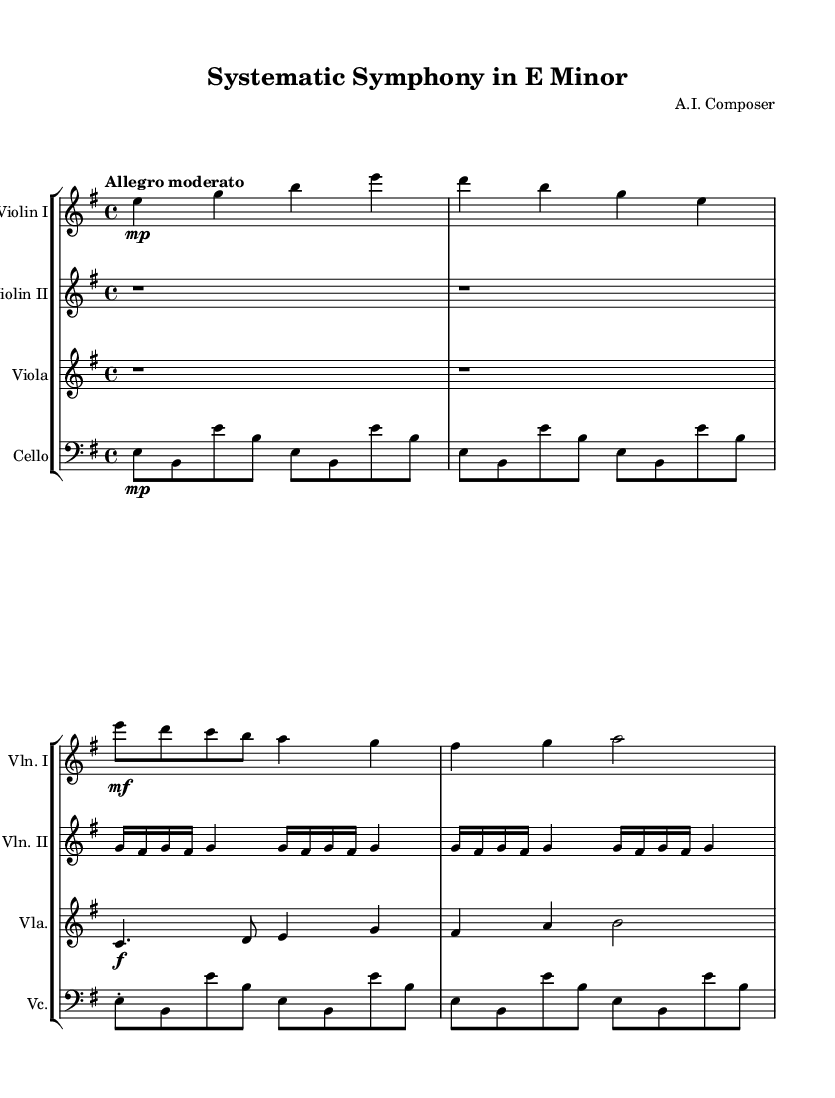What is the key signature of this music? The key signature shown for the piece is E minor, which has one sharp (F#). This is identifiable from the key signature notated at the beginning of the score.
Answer: E minor What is the time signature of this music? The time signature is indicated at the beginning of the music, which shows a 4/4 time signature. This means there are four beats in each measure and the quarter note gets one beat.
Answer: 4/4 What is the tempo marking for this piece? The tempo marking listed in the score is "Allegro moderato," which suggests a moderately fast tempo. The placement at the beginning of the score indicates the intended pacing for the performance.
Answer: Allegro moderato Which instruments are featured in this chamber music quartet? The score indicates the presence of four instruments: Violin I, Violin II, Viola, and Cello. Each instrument is labeled at the beginning of its respective staff.
Answer: Violin I, Violin II, Viola, Cello What is the first theme introduced in the music? The first theme introduced corresponds to the melody presented in the Violin I part, beginning with the notes E, D, C, B, A, and continuing from there. This theme is labeled as Theme A in the score.
Answer: Theme A How many measures does the introduction consist of? The introduction section features four measures in total, split between the entries from Violin I, Violin II, Viola, and Cello. Counting the measures visually from the score, one can determine the total.
Answer: 4 